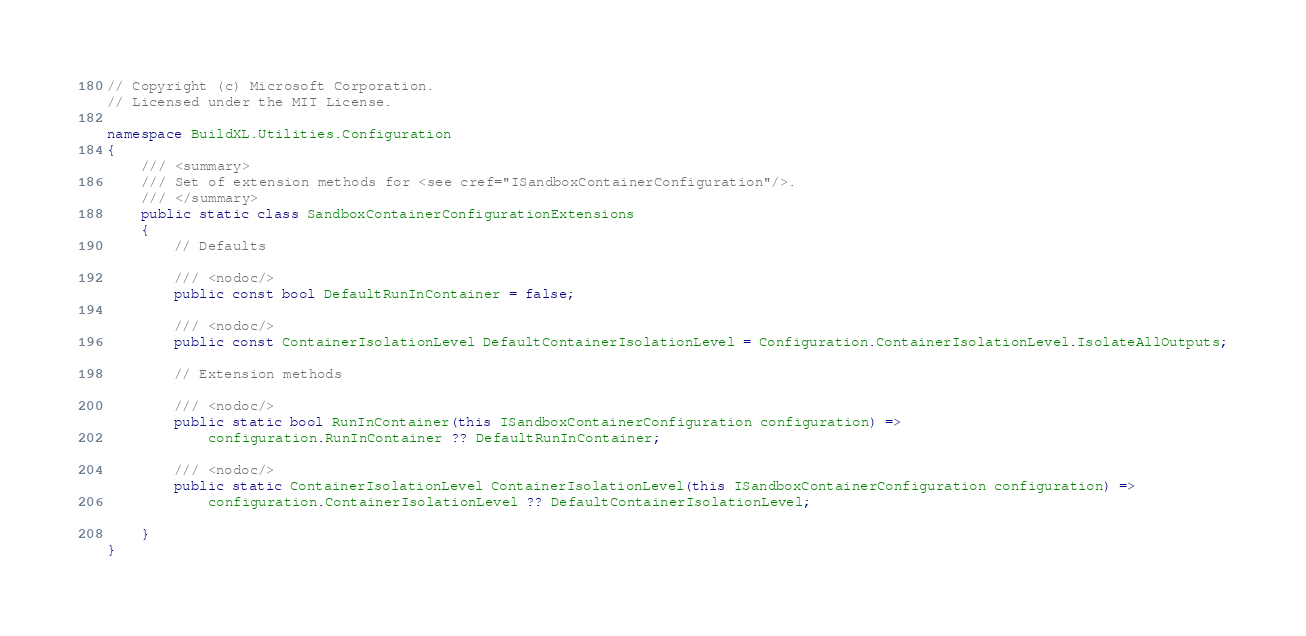Convert code to text. <code><loc_0><loc_0><loc_500><loc_500><_C#_>// Copyright (c) Microsoft Corporation.
// Licensed under the MIT License.

namespace BuildXL.Utilities.Configuration
{
    /// <summary>
    /// Set of extension methods for <see cref="ISandboxContainerConfiguration"/>.
    /// </summary>
    public static class SandboxContainerConfigurationExtensions
    {
        // Defaults

        /// <nodoc/>
        public const bool DefaultRunInContainer = false;

        /// <nodoc/>
        public const ContainerIsolationLevel DefaultContainerIsolationLevel = Configuration.ContainerIsolationLevel.IsolateAllOutputs;

        // Extension methods

        /// <nodoc/>
        public static bool RunInContainer(this ISandboxContainerConfiguration configuration) => 
            configuration.RunInContainer ?? DefaultRunInContainer;

        /// <nodoc/>
        public static ContainerIsolationLevel ContainerIsolationLevel(this ISandboxContainerConfiguration configuration) => 
            configuration.ContainerIsolationLevel ?? DefaultContainerIsolationLevel;

    }
}
</code> 